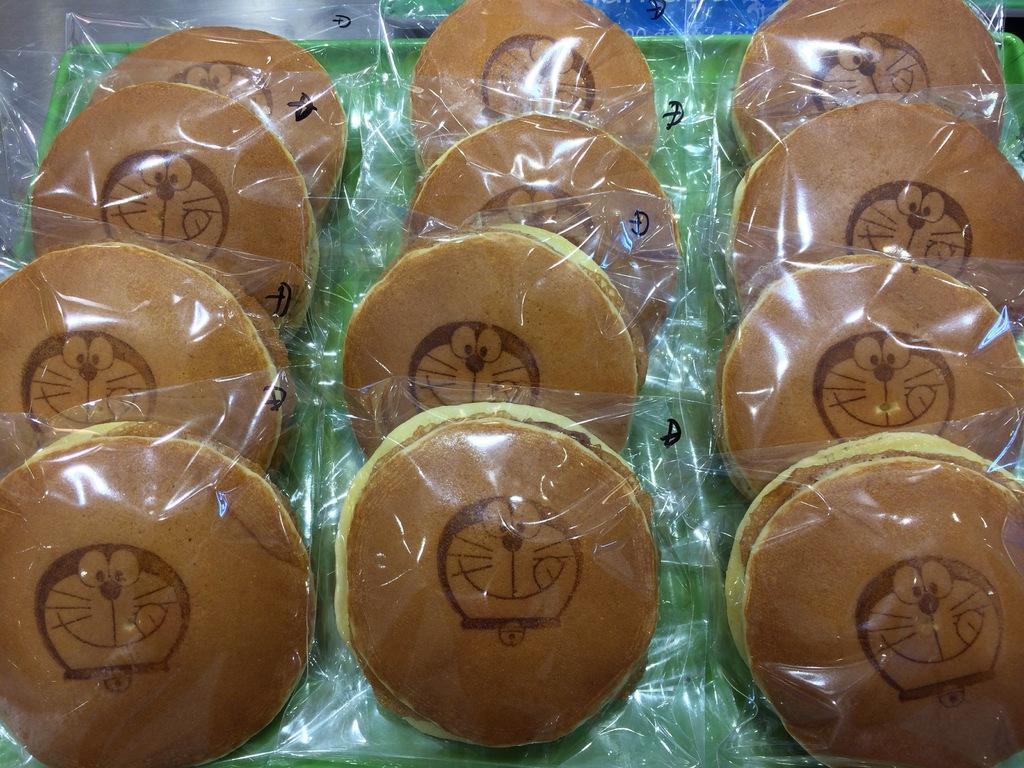How would you summarize this image in a sentence or two? In this image we can see a tray containing pancakes which are packed in polythene covers. 